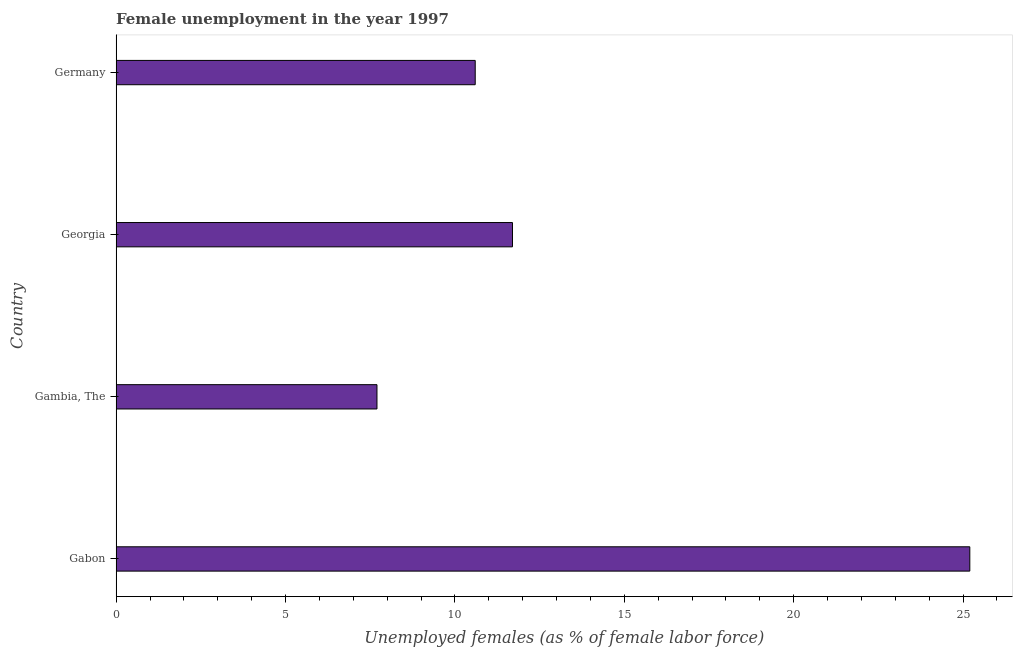Does the graph contain any zero values?
Provide a succinct answer. No. Does the graph contain grids?
Your answer should be very brief. No. What is the title of the graph?
Give a very brief answer. Female unemployment in the year 1997. What is the label or title of the X-axis?
Give a very brief answer. Unemployed females (as % of female labor force). What is the label or title of the Y-axis?
Give a very brief answer. Country. What is the unemployed females population in Gabon?
Ensure brevity in your answer.  25.2. Across all countries, what is the maximum unemployed females population?
Offer a very short reply. 25.2. Across all countries, what is the minimum unemployed females population?
Your answer should be compact. 7.7. In which country was the unemployed females population maximum?
Provide a succinct answer. Gabon. In which country was the unemployed females population minimum?
Your answer should be very brief. Gambia, The. What is the sum of the unemployed females population?
Provide a short and direct response. 55.2. What is the average unemployed females population per country?
Give a very brief answer. 13.8. What is the median unemployed females population?
Make the answer very short. 11.15. What is the ratio of the unemployed females population in Gabon to that in Germany?
Your answer should be compact. 2.38. What is the difference between the highest and the second highest unemployed females population?
Provide a short and direct response. 13.5. How many countries are there in the graph?
Give a very brief answer. 4. What is the difference between two consecutive major ticks on the X-axis?
Provide a succinct answer. 5. Are the values on the major ticks of X-axis written in scientific E-notation?
Your response must be concise. No. What is the Unemployed females (as % of female labor force) of Gabon?
Make the answer very short. 25.2. What is the Unemployed females (as % of female labor force) in Gambia, The?
Ensure brevity in your answer.  7.7. What is the Unemployed females (as % of female labor force) of Georgia?
Your answer should be compact. 11.7. What is the Unemployed females (as % of female labor force) in Germany?
Your answer should be compact. 10.6. What is the difference between the Unemployed females (as % of female labor force) in Gabon and Gambia, The?
Make the answer very short. 17.5. What is the difference between the Unemployed females (as % of female labor force) in Gabon and Georgia?
Your response must be concise. 13.5. What is the difference between the Unemployed females (as % of female labor force) in Gabon and Germany?
Give a very brief answer. 14.6. What is the difference between the Unemployed females (as % of female labor force) in Gambia, The and Georgia?
Your answer should be compact. -4. What is the difference between the Unemployed females (as % of female labor force) in Gambia, The and Germany?
Offer a very short reply. -2.9. What is the difference between the Unemployed females (as % of female labor force) in Georgia and Germany?
Offer a very short reply. 1.1. What is the ratio of the Unemployed females (as % of female labor force) in Gabon to that in Gambia, The?
Make the answer very short. 3.27. What is the ratio of the Unemployed females (as % of female labor force) in Gabon to that in Georgia?
Give a very brief answer. 2.15. What is the ratio of the Unemployed females (as % of female labor force) in Gabon to that in Germany?
Offer a very short reply. 2.38. What is the ratio of the Unemployed females (as % of female labor force) in Gambia, The to that in Georgia?
Offer a very short reply. 0.66. What is the ratio of the Unemployed females (as % of female labor force) in Gambia, The to that in Germany?
Offer a very short reply. 0.73. What is the ratio of the Unemployed females (as % of female labor force) in Georgia to that in Germany?
Offer a terse response. 1.1. 